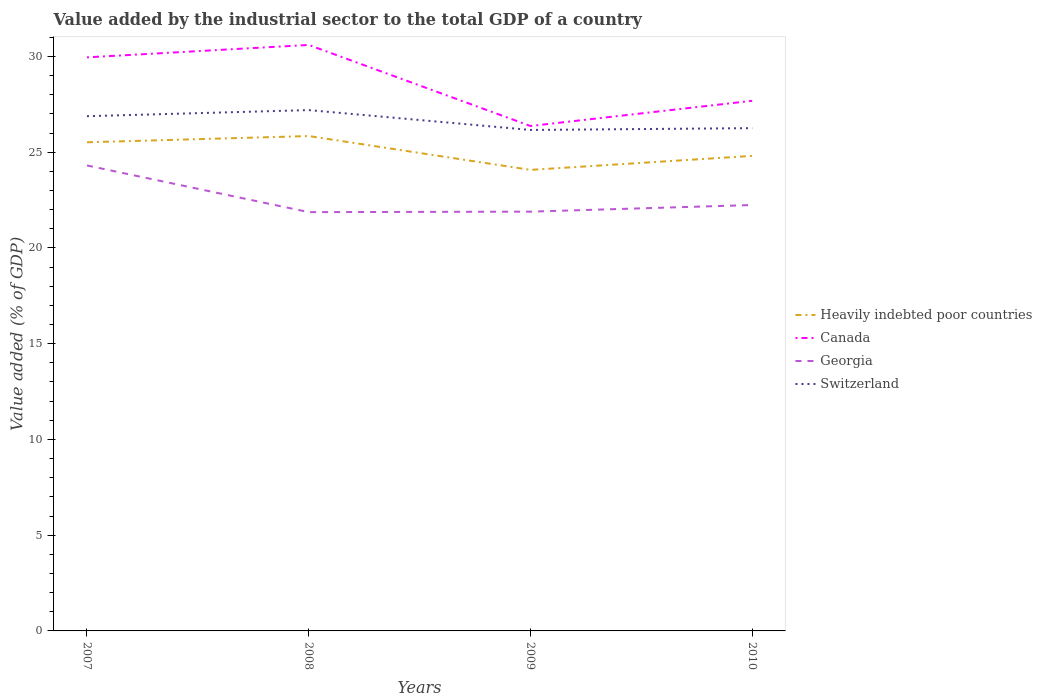Does the line corresponding to Switzerland intersect with the line corresponding to Canada?
Your answer should be very brief. No. Across all years, what is the maximum value added by the industrial sector to the total GDP in Canada?
Provide a succinct answer. 26.37. In which year was the value added by the industrial sector to the total GDP in Georgia maximum?
Your response must be concise. 2008. What is the total value added by the industrial sector to the total GDP in Georgia in the graph?
Your answer should be compact. 2.41. What is the difference between the highest and the second highest value added by the industrial sector to the total GDP in Heavily indebted poor countries?
Offer a terse response. 1.77. Is the value added by the industrial sector to the total GDP in Georgia strictly greater than the value added by the industrial sector to the total GDP in Canada over the years?
Provide a succinct answer. Yes. How many lines are there?
Keep it short and to the point. 4. How many years are there in the graph?
Make the answer very short. 4. What is the difference between two consecutive major ticks on the Y-axis?
Ensure brevity in your answer.  5. Are the values on the major ticks of Y-axis written in scientific E-notation?
Offer a terse response. No. How many legend labels are there?
Your response must be concise. 4. How are the legend labels stacked?
Provide a succinct answer. Vertical. What is the title of the graph?
Your answer should be compact. Value added by the industrial sector to the total GDP of a country. What is the label or title of the Y-axis?
Offer a very short reply. Value added (% of GDP). What is the Value added (% of GDP) of Heavily indebted poor countries in 2007?
Give a very brief answer. 25.52. What is the Value added (% of GDP) in Canada in 2007?
Keep it short and to the point. 29.95. What is the Value added (% of GDP) of Georgia in 2007?
Provide a short and direct response. 24.31. What is the Value added (% of GDP) in Switzerland in 2007?
Provide a succinct answer. 26.88. What is the Value added (% of GDP) in Heavily indebted poor countries in 2008?
Offer a terse response. 25.84. What is the Value added (% of GDP) in Canada in 2008?
Provide a succinct answer. 30.6. What is the Value added (% of GDP) of Georgia in 2008?
Make the answer very short. 21.87. What is the Value added (% of GDP) in Switzerland in 2008?
Ensure brevity in your answer.  27.2. What is the Value added (% of GDP) of Heavily indebted poor countries in 2009?
Offer a very short reply. 24.08. What is the Value added (% of GDP) in Canada in 2009?
Give a very brief answer. 26.37. What is the Value added (% of GDP) in Georgia in 2009?
Ensure brevity in your answer.  21.9. What is the Value added (% of GDP) of Switzerland in 2009?
Provide a succinct answer. 26.16. What is the Value added (% of GDP) in Heavily indebted poor countries in 2010?
Your response must be concise. 24.81. What is the Value added (% of GDP) of Canada in 2010?
Provide a short and direct response. 27.69. What is the Value added (% of GDP) of Georgia in 2010?
Offer a very short reply. 22.24. What is the Value added (% of GDP) of Switzerland in 2010?
Your answer should be very brief. 26.26. Across all years, what is the maximum Value added (% of GDP) in Heavily indebted poor countries?
Your answer should be very brief. 25.84. Across all years, what is the maximum Value added (% of GDP) in Canada?
Offer a terse response. 30.6. Across all years, what is the maximum Value added (% of GDP) of Georgia?
Make the answer very short. 24.31. Across all years, what is the maximum Value added (% of GDP) of Switzerland?
Provide a succinct answer. 27.2. Across all years, what is the minimum Value added (% of GDP) in Heavily indebted poor countries?
Make the answer very short. 24.08. Across all years, what is the minimum Value added (% of GDP) in Canada?
Your answer should be very brief. 26.37. Across all years, what is the minimum Value added (% of GDP) in Georgia?
Provide a short and direct response. 21.87. Across all years, what is the minimum Value added (% of GDP) of Switzerland?
Offer a terse response. 26.16. What is the total Value added (% of GDP) of Heavily indebted poor countries in the graph?
Make the answer very short. 100.25. What is the total Value added (% of GDP) of Canada in the graph?
Make the answer very short. 114.61. What is the total Value added (% of GDP) in Georgia in the graph?
Provide a short and direct response. 90.32. What is the total Value added (% of GDP) in Switzerland in the graph?
Offer a terse response. 106.5. What is the difference between the Value added (% of GDP) of Heavily indebted poor countries in 2007 and that in 2008?
Ensure brevity in your answer.  -0.33. What is the difference between the Value added (% of GDP) in Canada in 2007 and that in 2008?
Your response must be concise. -0.65. What is the difference between the Value added (% of GDP) in Georgia in 2007 and that in 2008?
Your answer should be compact. 2.44. What is the difference between the Value added (% of GDP) of Switzerland in 2007 and that in 2008?
Provide a succinct answer. -0.32. What is the difference between the Value added (% of GDP) of Heavily indebted poor countries in 2007 and that in 2009?
Keep it short and to the point. 1.44. What is the difference between the Value added (% of GDP) in Canada in 2007 and that in 2009?
Make the answer very short. 3.59. What is the difference between the Value added (% of GDP) in Georgia in 2007 and that in 2009?
Offer a very short reply. 2.41. What is the difference between the Value added (% of GDP) in Switzerland in 2007 and that in 2009?
Provide a short and direct response. 0.72. What is the difference between the Value added (% of GDP) in Heavily indebted poor countries in 2007 and that in 2010?
Offer a very short reply. 0.71. What is the difference between the Value added (% of GDP) of Canada in 2007 and that in 2010?
Your answer should be very brief. 2.27. What is the difference between the Value added (% of GDP) in Georgia in 2007 and that in 2010?
Offer a very short reply. 2.07. What is the difference between the Value added (% of GDP) of Switzerland in 2007 and that in 2010?
Your response must be concise. 0.62. What is the difference between the Value added (% of GDP) of Heavily indebted poor countries in 2008 and that in 2009?
Offer a very short reply. 1.77. What is the difference between the Value added (% of GDP) in Canada in 2008 and that in 2009?
Your response must be concise. 4.23. What is the difference between the Value added (% of GDP) in Georgia in 2008 and that in 2009?
Keep it short and to the point. -0.03. What is the difference between the Value added (% of GDP) of Switzerland in 2008 and that in 2009?
Provide a short and direct response. 1.04. What is the difference between the Value added (% of GDP) of Heavily indebted poor countries in 2008 and that in 2010?
Provide a short and direct response. 1.04. What is the difference between the Value added (% of GDP) in Canada in 2008 and that in 2010?
Your answer should be compact. 2.92. What is the difference between the Value added (% of GDP) of Georgia in 2008 and that in 2010?
Give a very brief answer. -0.37. What is the difference between the Value added (% of GDP) in Switzerland in 2008 and that in 2010?
Ensure brevity in your answer.  0.94. What is the difference between the Value added (% of GDP) in Heavily indebted poor countries in 2009 and that in 2010?
Make the answer very short. -0.73. What is the difference between the Value added (% of GDP) in Canada in 2009 and that in 2010?
Provide a short and direct response. -1.32. What is the difference between the Value added (% of GDP) of Georgia in 2009 and that in 2010?
Your answer should be very brief. -0.35. What is the difference between the Value added (% of GDP) in Switzerland in 2009 and that in 2010?
Make the answer very short. -0.09. What is the difference between the Value added (% of GDP) of Heavily indebted poor countries in 2007 and the Value added (% of GDP) of Canada in 2008?
Ensure brevity in your answer.  -5.08. What is the difference between the Value added (% of GDP) of Heavily indebted poor countries in 2007 and the Value added (% of GDP) of Georgia in 2008?
Offer a very short reply. 3.65. What is the difference between the Value added (% of GDP) of Heavily indebted poor countries in 2007 and the Value added (% of GDP) of Switzerland in 2008?
Provide a succinct answer. -1.68. What is the difference between the Value added (% of GDP) in Canada in 2007 and the Value added (% of GDP) in Georgia in 2008?
Offer a very short reply. 8.08. What is the difference between the Value added (% of GDP) in Canada in 2007 and the Value added (% of GDP) in Switzerland in 2008?
Keep it short and to the point. 2.75. What is the difference between the Value added (% of GDP) of Georgia in 2007 and the Value added (% of GDP) of Switzerland in 2008?
Offer a very short reply. -2.89. What is the difference between the Value added (% of GDP) of Heavily indebted poor countries in 2007 and the Value added (% of GDP) of Canada in 2009?
Your response must be concise. -0.85. What is the difference between the Value added (% of GDP) of Heavily indebted poor countries in 2007 and the Value added (% of GDP) of Georgia in 2009?
Ensure brevity in your answer.  3.62. What is the difference between the Value added (% of GDP) of Heavily indebted poor countries in 2007 and the Value added (% of GDP) of Switzerland in 2009?
Provide a short and direct response. -0.64. What is the difference between the Value added (% of GDP) in Canada in 2007 and the Value added (% of GDP) in Georgia in 2009?
Make the answer very short. 8.06. What is the difference between the Value added (% of GDP) of Canada in 2007 and the Value added (% of GDP) of Switzerland in 2009?
Offer a terse response. 3.79. What is the difference between the Value added (% of GDP) of Georgia in 2007 and the Value added (% of GDP) of Switzerland in 2009?
Your answer should be very brief. -1.85. What is the difference between the Value added (% of GDP) of Heavily indebted poor countries in 2007 and the Value added (% of GDP) of Canada in 2010?
Provide a succinct answer. -2.17. What is the difference between the Value added (% of GDP) of Heavily indebted poor countries in 2007 and the Value added (% of GDP) of Georgia in 2010?
Offer a terse response. 3.28. What is the difference between the Value added (% of GDP) in Heavily indebted poor countries in 2007 and the Value added (% of GDP) in Switzerland in 2010?
Provide a short and direct response. -0.74. What is the difference between the Value added (% of GDP) in Canada in 2007 and the Value added (% of GDP) in Georgia in 2010?
Your answer should be compact. 7.71. What is the difference between the Value added (% of GDP) of Canada in 2007 and the Value added (% of GDP) of Switzerland in 2010?
Keep it short and to the point. 3.7. What is the difference between the Value added (% of GDP) in Georgia in 2007 and the Value added (% of GDP) in Switzerland in 2010?
Ensure brevity in your answer.  -1.95. What is the difference between the Value added (% of GDP) of Heavily indebted poor countries in 2008 and the Value added (% of GDP) of Canada in 2009?
Keep it short and to the point. -0.53. What is the difference between the Value added (% of GDP) in Heavily indebted poor countries in 2008 and the Value added (% of GDP) in Georgia in 2009?
Keep it short and to the point. 3.95. What is the difference between the Value added (% of GDP) of Heavily indebted poor countries in 2008 and the Value added (% of GDP) of Switzerland in 2009?
Provide a short and direct response. -0.32. What is the difference between the Value added (% of GDP) of Canada in 2008 and the Value added (% of GDP) of Georgia in 2009?
Provide a short and direct response. 8.71. What is the difference between the Value added (% of GDP) in Canada in 2008 and the Value added (% of GDP) in Switzerland in 2009?
Keep it short and to the point. 4.44. What is the difference between the Value added (% of GDP) of Georgia in 2008 and the Value added (% of GDP) of Switzerland in 2009?
Offer a very short reply. -4.29. What is the difference between the Value added (% of GDP) of Heavily indebted poor countries in 2008 and the Value added (% of GDP) of Canada in 2010?
Ensure brevity in your answer.  -1.84. What is the difference between the Value added (% of GDP) of Heavily indebted poor countries in 2008 and the Value added (% of GDP) of Georgia in 2010?
Your answer should be compact. 3.6. What is the difference between the Value added (% of GDP) in Heavily indebted poor countries in 2008 and the Value added (% of GDP) in Switzerland in 2010?
Your answer should be compact. -0.41. What is the difference between the Value added (% of GDP) in Canada in 2008 and the Value added (% of GDP) in Georgia in 2010?
Keep it short and to the point. 8.36. What is the difference between the Value added (% of GDP) of Canada in 2008 and the Value added (% of GDP) of Switzerland in 2010?
Offer a terse response. 4.35. What is the difference between the Value added (% of GDP) in Georgia in 2008 and the Value added (% of GDP) in Switzerland in 2010?
Offer a terse response. -4.39. What is the difference between the Value added (% of GDP) of Heavily indebted poor countries in 2009 and the Value added (% of GDP) of Canada in 2010?
Your response must be concise. -3.61. What is the difference between the Value added (% of GDP) in Heavily indebted poor countries in 2009 and the Value added (% of GDP) in Georgia in 2010?
Ensure brevity in your answer.  1.83. What is the difference between the Value added (% of GDP) of Heavily indebted poor countries in 2009 and the Value added (% of GDP) of Switzerland in 2010?
Your answer should be very brief. -2.18. What is the difference between the Value added (% of GDP) of Canada in 2009 and the Value added (% of GDP) of Georgia in 2010?
Keep it short and to the point. 4.13. What is the difference between the Value added (% of GDP) in Canada in 2009 and the Value added (% of GDP) in Switzerland in 2010?
Your response must be concise. 0.11. What is the difference between the Value added (% of GDP) in Georgia in 2009 and the Value added (% of GDP) in Switzerland in 2010?
Your response must be concise. -4.36. What is the average Value added (% of GDP) of Heavily indebted poor countries per year?
Make the answer very short. 25.06. What is the average Value added (% of GDP) of Canada per year?
Your answer should be compact. 28.65. What is the average Value added (% of GDP) in Georgia per year?
Offer a terse response. 22.58. What is the average Value added (% of GDP) of Switzerland per year?
Offer a terse response. 26.63. In the year 2007, what is the difference between the Value added (% of GDP) of Heavily indebted poor countries and Value added (% of GDP) of Canada?
Your response must be concise. -4.44. In the year 2007, what is the difference between the Value added (% of GDP) of Heavily indebted poor countries and Value added (% of GDP) of Georgia?
Ensure brevity in your answer.  1.21. In the year 2007, what is the difference between the Value added (% of GDP) of Heavily indebted poor countries and Value added (% of GDP) of Switzerland?
Ensure brevity in your answer.  -1.36. In the year 2007, what is the difference between the Value added (% of GDP) in Canada and Value added (% of GDP) in Georgia?
Your answer should be compact. 5.65. In the year 2007, what is the difference between the Value added (% of GDP) of Canada and Value added (% of GDP) of Switzerland?
Offer a very short reply. 3.07. In the year 2007, what is the difference between the Value added (% of GDP) in Georgia and Value added (% of GDP) in Switzerland?
Your answer should be very brief. -2.57. In the year 2008, what is the difference between the Value added (% of GDP) in Heavily indebted poor countries and Value added (% of GDP) in Canada?
Ensure brevity in your answer.  -4.76. In the year 2008, what is the difference between the Value added (% of GDP) in Heavily indebted poor countries and Value added (% of GDP) in Georgia?
Your response must be concise. 3.97. In the year 2008, what is the difference between the Value added (% of GDP) of Heavily indebted poor countries and Value added (% of GDP) of Switzerland?
Offer a very short reply. -1.36. In the year 2008, what is the difference between the Value added (% of GDP) in Canada and Value added (% of GDP) in Georgia?
Your response must be concise. 8.73. In the year 2008, what is the difference between the Value added (% of GDP) in Canada and Value added (% of GDP) in Switzerland?
Make the answer very short. 3.4. In the year 2008, what is the difference between the Value added (% of GDP) of Georgia and Value added (% of GDP) of Switzerland?
Ensure brevity in your answer.  -5.33. In the year 2009, what is the difference between the Value added (% of GDP) in Heavily indebted poor countries and Value added (% of GDP) in Canada?
Offer a terse response. -2.29. In the year 2009, what is the difference between the Value added (% of GDP) in Heavily indebted poor countries and Value added (% of GDP) in Georgia?
Offer a terse response. 2.18. In the year 2009, what is the difference between the Value added (% of GDP) in Heavily indebted poor countries and Value added (% of GDP) in Switzerland?
Keep it short and to the point. -2.09. In the year 2009, what is the difference between the Value added (% of GDP) of Canada and Value added (% of GDP) of Georgia?
Your answer should be very brief. 4.47. In the year 2009, what is the difference between the Value added (% of GDP) of Canada and Value added (% of GDP) of Switzerland?
Make the answer very short. 0.21. In the year 2009, what is the difference between the Value added (% of GDP) in Georgia and Value added (% of GDP) in Switzerland?
Make the answer very short. -4.27. In the year 2010, what is the difference between the Value added (% of GDP) in Heavily indebted poor countries and Value added (% of GDP) in Canada?
Provide a short and direct response. -2.88. In the year 2010, what is the difference between the Value added (% of GDP) in Heavily indebted poor countries and Value added (% of GDP) in Georgia?
Provide a succinct answer. 2.57. In the year 2010, what is the difference between the Value added (% of GDP) in Heavily indebted poor countries and Value added (% of GDP) in Switzerland?
Provide a short and direct response. -1.45. In the year 2010, what is the difference between the Value added (% of GDP) in Canada and Value added (% of GDP) in Georgia?
Make the answer very short. 5.44. In the year 2010, what is the difference between the Value added (% of GDP) in Canada and Value added (% of GDP) in Switzerland?
Provide a succinct answer. 1.43. In the year 2010, what is the difference between the Value added (% of GDP) of Georgia and Value added (% of GDP) of Switzerland?
Provide a succinct answer. -4.01. What is the ratio of the Value added (% of GDP) of Heavily indebted poor countries in 2007 to that in 2008?
Offer a very short reply. 0.99. What is the ratio of the Value added (% of GDP) of Canada in 2007 to that in 2008?
Make the answer very short. 0.98. What is the ratio of the Value added (% of GDP) in Georgia in 2007 to that in 2008?
Provide a short and direct response. 1.11. What is the ratio of the Value added (% of GDP) in Switzerland in 2007 to that in 2008?
Provide a short and direct response. 0.99. What is the ratio of the Value added (% of GDP) of Heavily indebted poor countries in 2007 to that in 2009?
Offer a very short reply. 1.06. What is the ratio of the Value added (% of GDP) of Canada in 2007 to that in 2009?
Keep it short and to the point. 1.14. What is the ratio of the Value added (% of GDP) of Georgia in 2007 to that in 2009?
Provide a succinct answer. 1.11. What is the ratio of the Value added (% of GDP) of Switzerland in 2007 to that in 2009?
Offer a very short reply. 1.03. What is the ratio of the Value added (% of GDP) in Heavily indebted poor countries in 2007 to that in 2010?
Keep it short and to the point. 1.03. What is the ratio of the Value added (% of GDP) of Canada in 2007 to that in 2010?
Offer a terse response. 1.08. What is the ratio of the Value added (% of GDP) of Georgia in 2007 to that in 2010?
Offer a terse response. 1.09. What is the ratio of the Value added (% of GDP) in Switzerland in 2007 to that in 2010?
Provide a short and direct response. 1.02. What is the ratio of the Value added (% of GDP) in Heavily indebted poor countries in 2008 to that in 2009?
Offer a terse response. 1.07. What is the ratio of the Value added (% of GDP) of Canada in 2008 to that in 2009?
Give a very brief answer. 1.16. What is the ratio of the Value added (% of GDP) in Georgia in 2008 to that in 2009?
Provide a short and direct response. 1. What is the ratio of the Value added (% of GDP) of Switzerland in 2008 to that in 2009?
Give a very brief answer. 1.04. What is the ratio of the Value added (% of GDP) of Heavily indebted poor countries in 2008 to that in 2010?
Provide a succinct answer. 1.04. What is the ratio of the Value added (% of GDP) of Canada in 2008 to that in 2010?
Give a very brief answer. 1.11. What is the ratio of the Value added (% of GDP) in Georgia in 2008 to that in 2010?
Your answer should be very brief. 0.98. What is the ratio of the Value added (% of GDP) of Switzerland in 2008 to that in 2010?
Your response must be concise. 1.04. What is the ratio of the Value added (% of GDP) of Heavily indebted poor countries in 2009 to that in 2010?
Your answer should be compact. 0.97. What is the ratio of the Value added (% of GDP) in Canada in 2009 to that in 2010?
Offer a very short reply. 0.95. What is the ratio of the Value added (% of GDP) of Georgia in 2009 to that in 2010?
Provide a succinct answer. 0.98. What is the difference between the highest and the second highest Value added (% of GDP) in Heavily indebted poor countries?
Make the answer very short. 0.33. What is the difference between the highest and the second highest Value added (% of GDP) of Canada?
Your answer should be compact. 0.65. What is the difference between the highest and the second highest Value added (% of GDP) in Georgia?
Keep it short and to the point. 2.07. What is the difference between the highest and the second highest Value added (% of GDP) in Switzerland?
Your answer should be very brief. 0.32. What is the difference between the highest and the lowest Value added (% of GDP) in Heavily indebted poor countries?
Keep it short and to the point. 1.77. What is the difference between the highest and the lowest Value added (% of GDP) in Canada?
Provide a succinct answer. 4.23. What is the difference between the highest and the lowest Value added (% of GDP) of Georgia?
Offer a very short reply. 2.44. What is the difference between the highest and the lowest Value added (% of GDP) in Switzerland?
Your answer should be very brief. 1.04. 